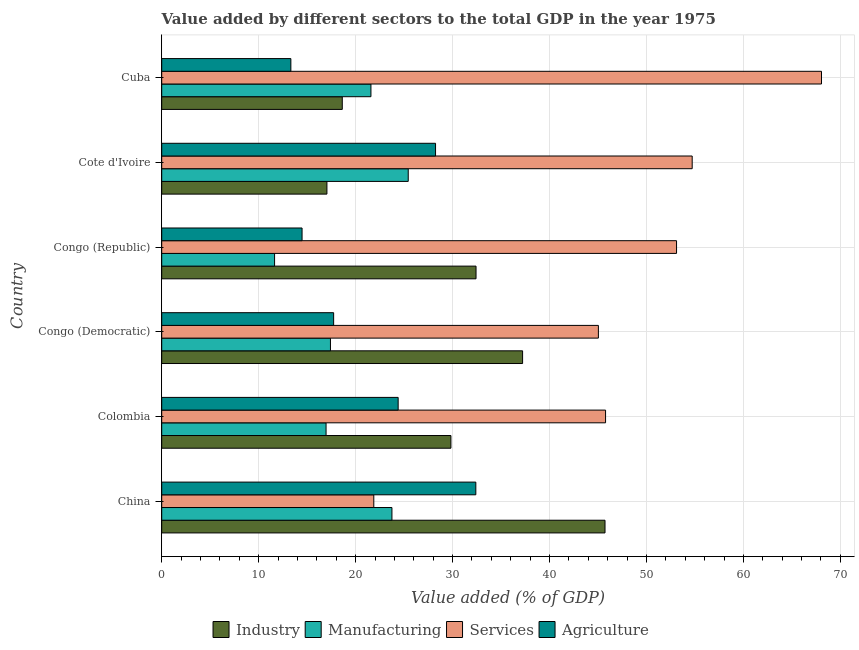How many groups of bars are there?
Make the answer very short. 6. Are the number of bars per tick equal to the number of legend labels?
Provide a short and direct response. Yes. Are the number of bars on each tick of the Y-axis equal?
Give a very brief answer. Yes. How many bars are there on the 4th tick from the bottom?
Give a very brief answer. 4. What is the label of the 4th group of bars from the top?
Offer a very short reply. Congo (Democratic). What is the value added by manufacturing sector in Colombia?
Give a very brief answer. 16.95. Across all countries, what is the maximum value added by industrial sector?
Your response must be concise. 45.72. Across all countries, what is the minimum value added by manufacturing sector?
Provide a succinct answer. 11.64. In which country was the value added by manufacturing sector maximum?
Your answer should be very brief. Cote d'Ivoire. In which country was the value added by industrial sector minimum?
Give a very brief answer. Cote d'Ivoire. What is the total value added by manufacturing sector in the graph?
Offer a very short reply. 116.75. What is the difference between the value added by agricultural sector in Congo (Democratic) and that in Cote d'Ivoire?
Your response must be concise. -10.51. What is the difference between the value added by manufacturing sector in China and the value added by agricultural sector in Colombia?
Your answer should be very brief. -0.64. What is the average value added by agricultural sector per country?
Ensure brevity in your answer.  21.76. What is the difference between the value added by industrial sector and value added by services sector in Congo (Republic)?
Keep it short and to the point. -20.68. What is the ratio of the value added by industrial sector in China to that in Congo (Republic)?
Ensure brevity in your answer.  1.41. Is the value added by services sector in China less than that in Cote d'Ivoire?
Make the answer very short. Yes. What is the difference between the highest and the second highest value added by industrial sector?
Offer a terse response. 8.5. What is the difference between the highest and the lowest value added by agricultural sector?
Your answer should be compact. 19.08. Is the sum of the value added by agricultural sector in China and Cuba greater than the maximum value added by manufacturing sector across all countries?
Make the answer very short. Yes. Is it the case that in every country, the sum of the value added by services sector and value added by industrial sector is greater than the sum of value added by manufacturing sector and value added by agricultural sector?
Provide a succinct answer. Yes. What does the 3rd bar from the top in Congo (Republic) represents?
Offer a terse response. Manufacturing. What does the 4th bar from the bottom in Congo (Republic) represents?
Give a very brief answer. Agriculture. How many bars are there?
Your answer should be compact. 24. How many countries are there in the graph?
Your answer should be compact. 6. What is the difference between two consecutive major ticks on the X-axis?
Your response must be concise. 10. Does the graph contain any zero values?
Keep it short and to the point. No. Does the graph contain grids?
Ensure brevity in your answer.  Yes. Where does the legend appear in the graph?
Your answer should be compact. Bottom center. How many legend labels are there?
Give a very brief answer. 4. How are the legend labels stacked?
Ensure brevity in your answer.  Horizontal. What is the title of the graph?
Make the answer very short. Value added by different sectors to the total GDP in the year 1975. What is the label or title of the X-axis?
Offer a very short reply. Value added (% of GDP). What is the label or title of the Y-axis?
Your response must be concise. Country. What is the Value added (% of GDP) of Industry in China?
Keep it short and to the point. 45.72. What is the Value added (% of GDP) of Manufacturing in China?
Keep it short and to the point. 23.75. What is the Value added (% of GDP) in Services in China?
Make the answer very short. 21.88. What is the Value added (% of GDP) of Agriculture in China?
Give a very brief answer. 32.4. What is the Value added (% of GDP) of Industry in Colombia?
Make the answer very short. 29.83. What is the Value added (% of GDP) of Manufacturing in Colombia?
Give a very brief answer. 16.95. What is the Value added (% of GDP) in Services in Colombia?
Provide a short and direct response. 45.78. What is the Value added (% of GDP) in Agriculture in Colombia?
Give a very brief answer. 24.39. What is the Value added (% of GDP) in Industry in Congo (Democratic)?
Ensure brevity in your answer.  37.22. What is the Value added (% of GDP) in Manufacturing in Congo (Democratic)?
Provide a short and direct response. 17.41. What is the Value added (% of GDP) of Services in Congo (Democratic)?
Your answer should be compact. 45.04. What is the Value added (% of GDP) in Agriculture in Congo (Democratic)?
Give a very brief answer. 17.73. What is the Value added (% of GDP) of Industry in Congo (Republic)?
Give a very brief answer. 32.42. What is the Value added (% of GDP) in Manufacturing in Congo (Republic)?
Provide a succinct answer. 11.64. What is the Value added (% of GDP) of Services in Congo (Republic)?
Ensure brevity in your answer.  53.1. What is the Value added (% of GDP) of Agriculture in Congo (Republic)?
Ensure brevity in your answer.  14.48. What is the Value added (% of GDP) in Industry in Cote d'Ivoire?
Provide a succinct answer. 17.04. What is the Value added (% of GDP) in Manufacturing in Cote d'Ivoire?
Ensure brevity in your answer.  25.43. What is the Value added (% of GDP) in Services in Cote d'Ivoire?
Your response must be concise. 54.72. What is the Value added (% of GDP) of Agriculture in Cote d'Ivoire?
Your answer should be compact. 28.24. What is the Value added (% of GDP) in Industry in Cuba?
Make the answer very short. 18.62. What is the Value added (% of GDP) of Manufacturing in Cuba?
Offer a terse response. 21.58. What is the Value added (% of GDP) of Services in Cuba?
Offer a terse response. 68.05. What is the Value added (% of GDP) of Agriculture in Cuba?
Make the answer very short. 13.32. Across all countries, what is the maximum Value added (% of GDP) in Industry?
Your response must be concise. 45.72. Across all countries, what is the maximum Value added (% of GDP) of Manufacturing?
Provide a short and direct response. 25.43. Across all countries, what is the maximum Value added (% of GDP) of Services?
Provide a succinct answer. 68.05. Across all countries, what is the maximum Value added (% of GDP) in Agriculture?
Offer a very short reply. 32.4. Across all countries, what is the minimum Value added (% of GDP) in Industry?
Provide a succinct answer. 17.04. Across all countries, what is the minimum Value added (% of GDP) in Manufacturing?
Your answer should be compact. 11.64. Across all countries, what is the minimum Value added (% of GDP) of Services?
Give a very brief answer. 21.88. Across all countries, what is the minimum Value added (% of GDP) of Agriculture?
Give a very brief answer. 13.32. What is the total Value added (% of GDP) of Industry in the graph?
Keep it short and to the point. 180.87. What is the total Value added (% of GDP) in Manufacturing in the graph?
Provide a short and direct response. 116.75. What is the total Value added (% of GDP) of Services in the graph?
Ensure brevity in your answer.  288.57. What is the total Value added (% of GDP) of Agriculture in the graph?
Ensure brevity in your answer.  130.56. What is the difference between the Value added (% of GDP) in Industry in China and that in Colombia?
Ensure brevity in your answer.  15.89. What is the difference between the Value added (% of GDP) in Manufacturing in China and that in Colombia?
Ensure brevity in your answer.  6.79. What is the difference between the Value added (% of GDP) of Services in China and that in Colombia?
Keep it short and to the point. -23.9. What is the difference between the Value added (% of GDP) of Agriculture in China and that in Colombia?
Offer a terse response. 8.01. What is the difference between the Value added (% of GDP) of Industry in China and that in Congo (Democratic)?
Your answer should be compact. 8.5. What is the difference between the Value added (% of GDP) in Manufacturing in China and that in Congo (Democratic)?
Offer a terse response. 6.34. What is the difference between the Value added (% of GDP) in Services in China and that in Congo (Democratic)?
Give a very brief answer. -23.17. What is the difference between the Value added (% of GDP) in Agriculture in China and that in Congo (Democratic)?
Provide a succinct answer. 14.66. What is the difference between the Value added (% of GDP) in Industry in China and that in Congo (Republic)?
Offer a very short reply. 13.3. What is the difference between the Value added (% of GDP) in Manufacturing in China and that in Congo (Republic)?
Your answer should be very brief. 12.11. What is the difference between the Value added (% of GDP) in Services in China and that in Congo (Republic)?
Give a very brief answer. -31.23. What is the difference between the Value added (% of GDP) in Agriculture in China and that in Congo (Republic)?
Your answer should be compact. 17.92. What is the difference between the Value added (% of GDP) in Industry in China and that in Cote d'Ivoire?
Provide a short and direct response. 28.68. What is the difference between the Value added (% of GDP) of Manufacturing in China and that in Cote d'Ivoire?
Give a very brief answer. -1.68. What is the difference between the Value added (% of GDP) in Services in China and that in Cote d'Ivoire?
Provide a short and direct response. -32.84. What is the difference between the Value added (% of GDP) in Agriculture in China and that in Cote d'Ivoire?
Ensure brevity in your answer.  4.15. What is the difference between the Value added (% of GDP) in Industry in China and that in Cuba?
Provide a succinct answer. 27.1. What is the difference between the Value added (% of GDP) of Manufacturing in China and that in Cuba?
Offer a very short reply. 2.17. What is the difference between the Value added (% of GDP) of Services in China and that in Cuba?
Offer a very short reply. -46.18. What is the difference between the Value added (% of GDP) of Agriculture in China and that in Cuba?
Provide a succinct answer. 19.08. What is the difference between the Value added (% of GDP) in Industry in Colombia and that in Congo (Democratic)?
Offer a terse response. -7.39. What is the difference between the Value added (% of GDP) in Manufacturing in Colombia and that in Congo (Democratic)?
Offer a terse response. -0.45. What is the difference between the Value added (% of GDP) of Services in Colombia and that in Congo (Democratic)?
Give a very brief answer. 0.74. What is the difference between the Value added (% of GDP) in Agriculture in Colombia and that in Congo (Democratic)?
Give a very brief answer. 6.65. What is the difference between the Value added (% of GDP) of Industry in Colombia and that in Congo (Republic)?
Ensure brevity in your answer.  -2.59. What is the difference between the Value added (% of GDP) of Manufacturing in Colombia and that in Congo (Republic)?
Make the answer very short. 5.31. What is the difference between the Value added (% of GDP) of Services in Colombia and that in Congo (Republic)?
Your response must be concise. -7.32. What is the difference between the Value added (% of GDP) of Agriculture in Colombia and that in Congo (Republic)?
Give a very brief answer. 9.91. What is the difference between the Value added (% of GDP) of Industry in Colombia and that in Cote d'Ivoire?
Offer a very short reply. 12.79. What is the difference between the Value added (% of GDP) in Manufacturing in Colombia and that in Cote d'Ivoire?
Offer a very short reply. -8.48. What is the difference between the Value added (% of GDP) of Services in Colombia and that in Cote d'Ivoire?
Give a very brief answer. -8.93. What is the difference between the Value added (% of GDP) in Agriculture in Colombia and that in Cote d'Ivoire?
Provide a short and direct response. -3.86. What is the difference between the Value added (% of GDP) of Industry in Colombia and that in Cuba?
Provide a short and direct response. 11.21. What is the difference between the Value added (% of GDP) in Manufacturing in Colombia and that in Cuba?
Offer a very short reply. -4.63. What is the difference between the Value added (% of GDP) of Services in Colombia and that in Cuba?
Your answer should be compact. -22.27. What is the difference between the Value added (% of GDP) in Agriculture in Colombia and that in Cuba?
Offer a very short reply. 11.07. What is the difference between the Value added (% of GDP) of Industry in Congo (Democratic) and that in Congo (Republic)?
Your answer should be compact. 4.8. What is the difference between the Value added (% of GDP) of Manufacturing in Congo (Democratic) and that in Congo (Republic)?
Provide a short and direct response. 5.76. What is the difference between the Value added (% of GDP) of Services in Congo (Democratic) and that in Congo (Republic)?
Give a very brief answer. -8.06. What is the difference between the Value added (% of GDP) in Agriculture in Congo (Democratic) and that in Congo (Republic)?
Your answer should be very brief. 3.26. What is the difference between the Value added (% of GDP) in Industry in Congo (Democratic) and that in Cote d'Ivoire?
Your answer should be very brief. 20.18. What is the difference between the Value added (% of GDP) in Manufacturing in Congo (Democratic) and that in Cote d'Ivoire?
Ensure brevity in your answer.  -8.02. What is the difference between the Value added (% of GDP) in Services in Congo (Democratic) and that in Cote d'Ivoire?
Provide a short and direct response. -9.67. What is the difference between the Value added (% of GDP) of Agriculture in Congo (Democratic) and that in Cote d'Ivoire?
Your answer should be very brief. -10.51. What is the difference between the Value added (% of GDP) in Industry in Congo (Democratic) and that in Cuba?
Keep it short and to the point. 18.6. What is the difference between the Value added (% of GDP) in Manufacturing in Congo (Democratic) and that in Cuba?
Offer a very short reply. -4.17. What is the difference between the Value added (% of GDP) in Services in Congo (Democratic) and that in Cuba?
Give a very brief answer. -23.01. What is the difference between the Value added (% of GDP) in Agriculture in Congo (Democratic) and that in Cuba?
Provide a succinct answer. 4.41. What is the difference between the Value added (% of GDP) of Industry in Congo (Republic) and that in Cote d'Ivoire?
Your answer should be very brief. 15.38. What is the difference between the Value added (% of GDP) of Manufacturing in Congo (Republic) and that in Cote d'Ivoire?
Ensure brevity in your answer.  -13.79. What is the difference between the Value added (% of GDP) of Services in Congo (Republic) and that in Cote d'Ivoire?
Make the answer very short. -1.61. What is the difference between the Value added (% of GDP) in Agriculture in Congo (Republic) and that in Cote d'Ivoire?
Your response must be concise. -13.77. What is the difference between the Value added (% of GDP) of Industry in Congo (Republic) and that in Cuba?
Provide a short and direct response. 13.8. What is the difference between the Value added (% of GDP) of Manufacturing in Congo (Republic) and that in Cuba?
Offer a terse response. -9.94. What is the difference between the Value added (% of GDP) in Services in Congo (Republic) and that in Cuba?
Offer a terse response. -14.95. What is the difference between the Value added (% of GDP) of Agriculture in Congo (Republic) and that in Cuba?
Offer a terse response. 1.16. What is the difference between the Value added (% of GDP) of Industry in Cote d'Ivoire and that in Cuba?
Ensure brevity in your answer.  -1.58. What is the difference between the Value added (% of GDP) in Manufacturing in Cote d'Ivoire and that in Cuba?
Provide a succinct answer. 3.85. What is the difference between the Value added (% of GDP) in Services in Cote d'Ivoire and that in Cuba?
Make the answer very short. -13.34. What is the difference between the Value added (% of GDP) of Agriculture in Cote d'Ivoire and that in Cuba?
Give a very brief answer. 14.92. What is the difference between the Value added (% of GDP) in Industry in China and the Value added (% of GDP) in Manufacturing in Colombia?
Provide a short and direct response. 28.77. What is the difference between the Value added (% of GDP) in Industry in China and the Value added (% of GDP) in Services in Colombia?
Your answer should be very brief. -0.06. What is the difference between the Value added (% of GDP) of Industry in China and the Value added (% of GDP) of Agriculture in Colombia?
Keep it short and to the point. 21.34. What is the difference between the Value added (% of GDP) of Manufacturing in China and the Value added (% of GDP) of Services in Colombia?
Make the answer very short. -22.03. What is the difference between the Value added (% of GDP) in Manufacturing in China and the Value added (% of GDP) in Agriculture in Colombia?
Your answer should be very brief. -0.64. What is the difference between the Value added (% of GDP) in Services in China and the Value added (% of GDP) in Agriculture in Colombia?
Give a very brief answer. -2.51. What is the difference between the Value added (% of GDP) of Industry in China and the Value added (% of GDP) of Manufacturing in Congo (Democratic)?
Offer a terse response. 28.32. What is the difference between the Value added (% of GDP) in Industry in China and the Value added (% of GDP) in Services in Congo (Democratic)?
Provide a succinct answer. 0.68. What is the difference between the Value added (% of GDP) in Industry in China and the Value added (% of GDP) in Agriculture in Congo (Democratic)?
Offer a terse response. 27.99. What is the difference between the Value added (% of GDP) in Manufacturing in China and the Value added (% of GDP) in Services in Congo (Democratic)?
Your answer should be compact. -21.3. What is the difference between the Value added (% of GDP) in Manufacturing in China and the Value added (% of GDP) in Agriculture in Congo (Democratic)?
Your answer should be compact. 6.01. What is the difference between the Value added (% of GDP) of Services in China and the Value added (% of GDP) of Agriculture in Congo (Democratic)?
Offer a very short reply. 4.14. What is the difference between the Value added (% of GDP) of Industry in China and the Value added (% of GDP) of Manufacturing in Congo (Republic)?
Make the answer very short. 34.08. What is the difference between the Value added (% of GDP) in Industry in China and the Value added (% of GDP) in Services in Congo (Republic)?
Provide a short and direct response. -7.38. What is the difference between the Value added (% of GDP) of Industry in China and the Value added (% of GDP) of Agriculture in Congo (Republic)?
Provide a succinct answer. 31.25. What is the difference between the Value added (% of GDP) of Manufacturing in China and the Value added (% of GDP) of Services in Congo (Republic)?
Make the answer very short. -29.36. What is the difference between the Value added (% of GDP) of Manufacturing in China and the Value added (% of GDP) of Agriculture in Congo (Republic)?
Offer a very short reply. 9.27. What is the difference between the Value added (% of GDP) in Services in China and the Value added (% of GDP) in Agriculture in Congo (Republic)?
Give a very brief answer. 7.4. What is the difference between the Value added (% of GDP) in Industry in China and the Value added (% of GDP) in Manufacturing in Cote d'Ivoire?
Your response must be concise. 20.3. What is the difference between the Value added (% of GDP) of Industry in China and the Value added (% of GDP) of Services in Cote d'Ivoire?
Offer a terse response. -8.99. What is the difference between the Value added (% of GDP) in Industry in China and the Value added (% of GDP) in Agriculture in Cote d'Ivoire?
Keep it short and to the point. 17.48. What is the difference between the Value added (% of GDP) in Manufacturing in China and the Value added (% of GDP) in Services in Cote d'Ivoire?
Ensure brevity in your answer.  -30.97. What is the difference between the Value added (% of GDP) of Manufacturing in China and the Value added (% of GDP) of Agriculture in Cote d'Ivoire?
Provide a succinct answer. -4.5. What is the difference between the Value added (% of GDP) of Services in China and the Value added (% of GDP) of Agriculture in Cote d'Ivoire?
Give a very brief answer. -6.37. What is the difference between the Value added (% of GDP) in Industry in China and the Value added (% of GDP) in Manufacturing in Cuba?
Keep it short and to the point. 24.14. What is the difference between the Value added (% of GDP) of Industry in China and the Value added (% of GDP) of Services in Cuba?
Your answer should be compact. -22.33. What is the difference between the Value added (% of GDP) of Industry in China and the Value added (% of GDP) of Agriculture in Cuba?
Offer a terse response. 32.4. What is the difference between the Value added (% of GDP) in Manufacturing in China and the Value added (% of GDP) in Services in Cuba?
Your answer should be very brief. -44.31. What is the difference between the Value added (% of GDP) of Manufacturing in China and the Value added (% of GDP) of Agriculture in Cuba?
Your response must be concise. 10.43. What is the difference between the Value added (% of GDP) of Services in China and the Value added (% of GDP) of Agriculture in Cuba?
Ensure brevity in your answer.  8.56. What is the difference between the Value added (% of GDP) of Industry in Colombia and the Value added (% of GDP) of Manufacturing in Congo (Democratic)?
Provide a succinct answer. 12.43. What is the difference between the Value added (% of GDP) of Industry in Colombia and the Value added (% of GDP) of Services in Congo (Democratic)?
Your answer should be very brief. -15.21. What is the difference between the Value added (% of GDP) in Industry in Colombia and the Value added (% of GDP) in Agriculture in Congo (Democratic)?
Your answer should be compact. 12.1. What is the difference between the Value added (% of GDP) in Manufacturing in Colombia and the Value added (% of GDP) in Services in Congo (Democratic)?
Provide a succinct answer. -28.09. What is the difference between the Value added (% of GDP) of Manufacturing in Colombia and the Value added (% of GDP) of Agriculture in Congo (Democratic)?
Your answer should be compact. -0.78. What is the difference between the Value added (% of GDP) in Services in Colombia and the Value added (% of GDP) in Agriculture in Congo (Democratic)?
Make the answer very short. 28.05. What is the difference between the Value added (% of GDP) of Industry in Colombia and the Value added (% of GDP) of Manufacturing in Congo (Republic)?
Offer a very short reply. 18.19. What is the difference between the Value added (% of GDP) in Industry in Colombia and the Value added (% of GDP) in Services in Congo (Republic)?
Make the answer very short. -23.27. What is the difference between the Value added (% of GDP) in Industry in Colombia and the Value added (% of GDP) in Agriculture in Congo (Republic)?
Offer a terse response. 15.35. What is the difference between the Value added (% of GDP) of Manufacturing in Colombia and the Value added (% of GDP) of Services in Congo (Republic)?
Provide a succinct answer. -36.15. What is the difference between the Value added (% of GDP) in Manufacturing in Colombia and the Value added (% of GDP) in Agriculture in Congo (Republic)?
Ensure brevity in your answer.  2.47. What is the difference between the Value added (% of GDP) in Services in Colombia and the Value added (% of GDP) in Agriculture in Congo (Republic)?
Offer a terse response. 31.3. What is the difference between the Value added (% of GDP) in Industry in Colombia and the Value added (% of GDP) in Manufacturing in Cote d'Ivoire?
Ensure brevity in your answer.  4.4. What is the difference between the Value added (% of GDP) of Industry in Colombia and the Value added (% of GDP) of Services in Cote d'Ivoire?
Provide a short and direct response. -24.88. What is the difference between the Value added (% of GDP) of Industry in Colombia and the Value added (% of GDP) of Agriculture in Cote d'Ivoire?
Your response must be concise. 1.59. What is the difference between the Value added (% of GDP) of Manufacturing in Colombia and the Value added (% of GDP) of Services in Cote d'Ivoire?
Provide a succinct answer. -37.76. What is the difference between the Value added (% of GDP) in Manufacturing in Colombia and the Value added (% of GDP) in Agriculture in Cote d'Ivoire?
Provide a short and direct response. -11.29. What is the difference between the Value added (% of GDP) in Services in Colombia and the Value added (% of GDP) in Agriculture in Cote d'Ivoire?
Your response must be concise. 17.54. What is the difference between the Value added (% of GDP) in Industry in Colombia and the Value added (% of GDP) in Manufacturing in Cuba?
Make the answer very short. 8.25. What is the difference between the Value added (% of GDP) in Industry in Colombia and the Value added (% of GDP) in Services in Cuba?
Give a very brief answer. -38.22. What is the difference between the Value added (% of GDP) in Industry in Colombia and the Value added (% of GDP) in Agriculture in Cuba?
Offer a terse response. 16.51. What is the difference between the Value added (% of GDP) of Manufacturing in Colombia and the Value added (% of GDP) of Services in Cuba?
Your answer should be compact. -51.1. What is the difference between the Value added (% of GDP) in Manufacturing in Colombia and the Value added (% of GDP) in Agriculture in Cuba?
Make the answer very short. 3.63. What is the difference between the Value added (% of GDP) in Services in Colombia and the Value added (% of GDP) in Agriculture in Cuba?
Provide a short and direct response. 32.46. What is the difference between the Value added (% of GDP) of Industry in Congo (Democratic) and the Value added (% of GDP) of Manufacturing in Congo (Republic)?
Provide a short and direct response. 25.58. What is the difference between the Value added (% of GDP) of Industry in Congo (Democratic) and the Value added (% of GDP) of Services in Congo (Republic)?
Keep it short and to the point. -15.88. What is the difference between the Value added (% of GDP) in Industry in Congo (Democratic) and the Value added (% of GDP) in Agriculture in Congo (Republic)?
Offer a very short reply. 22.75. What is the difference between the Value added (% of GDP) of Manufacturing in Congo (Democratic) and the Value added (% of GDP) of Services in Congo (Republic)?
Give a very brief answer. -35.7. What is the difference between the Value added (% of GDP) in Manufacturing in Congo (Democratic) and the Value added (% of GDP) in Agriculture in Congo (Republic)?
Give a very brief answer. 2.93. What is the difference between the Value added (% of GDP) in Services in Congo (Democratic) and the Value added (% of GDP) in Agriculture in Congo (Republic)?
Your answer should be compact. 30.56. What is the difference between the Value added (% of GDP) in Industry in Congo (Democratic) and the Value added (% of GDP) in Manufacturing in Cote d'Ivoire?
Your answer should be compact. 11.8. What is the difference between the Value added (% of GDP) of Industry in Congo (Democratic) and the Value added (% of GDP) of Services in Cote d'Ivoire?
Give a very brief answer. -17.49. What is the difference between the Value added (% of GDP) in Industry in Congo (Democratic) and the Value added (% of GDP) in Agriculture in Cote d'Ivoire?
Make the answer very short. 8.98. What is the difference between the Value added (% of GDP) of Manufacturing in Congo (Democratic) and the Value added (% of GDP) of Services in Cote d'Ivoire?
Offer a very short reply. -37.31. What is the difference between the Value added (% of GDP) of Manufacturing in Congo (Democratic) and the Value added (% of GDP) of Agriculture in Cote d'Ivoire?
Make the answer very short. -10.84. What is the difference between the Value added (% of GDP) of Services in Congo (Democratic) and the Value added (% of GDP) of Agriculture in Cote d'Ivoire?
Provide a succinct answer. 16.8. What is the difference between the Value added (% of GDP) of Industry in Congo (Democratic) and the Value added (% of GDP) of Manufacturing in Cuba?
Provide a short and direct response. 15.64. What is the difference between the Value added (% of GDP) of Industry in Congo (Democratic) and the Value added (% of GDP) of Services in Cuba?
Your answer should be very brief. -30.83. What is the difference between the Value added (% of GDP) in Industry in Congo (Democratic) and the Value added (% of GDP) in Agriculture in Cuba?
Your answer should be compact. 23.9. What is the difference between the Value added (% of GDP) in Manufacturing in Congo (Democratic) and the Value added (% of GDP) in Services in Cuba?
Provide a short and direct response. -50.65. What is the difference between the Value added (% of GDP) in Manufacturing in Congo (Democratic) and the Value added (% of GDP) in Agriculture in Cuba?
Your answer should be very brief. 4.08. What is the difference between the Value added (% of GDP) of Services in Congo (Democratic) and the Value added (% of GDP) of Agriculture in Cuba?
Offer a terse response. 31.72. What is the difference between the Value added (% of GDP) in Industry in Congo (Republic) and the Value added (% of GDP) in Manufacturing in Cote d'Ivoire?
Make the answer very short. 6.99. What is the difference between the Value added (% of GDP) of Industry in Congo (Republic) and the Value added (% of GDP) of Services in Cote d'Ivoire?
Ensure brevity in your answer.  -22.29. What is the difference between the Value added (% of GDP) of Industry in Congo (Republic) and the Value added (% of GDP) of Agriculture in Cote d'Ivoire?
Your response must be concise. 4.18. What is the difference between the Value added (% of GDP) in Manufacturing in Congo (Republic) and the Value added (% of GDP) in Services in Cote d'Ivoire?
Keep it short and to the point. -43.07. What is the difference between the Value added (% of GDP) of Manufacturing in Congo (Republic) and the Value added (% of GDP) of Agriculture in Cote d'Ivoire?
Your answer should be compact. -16.6. What is the difference between the Value added (% of GDP) of Services in Congo (Republic) and the Value added (% of GDP) of Agriculture in Cote d'Ivoire?
Your answer should be compact. 24.86. What is the difference between the Value added (% of GDP) in Industry in Congo (Republic) and the Value added (% of GDP) in Manufacturing in Cuba?
Give a very brief answer. 10.84. What is the difference between the Value added (% of GDP) of Industry in Congo (Republic) and the Value added (% of GDP) of Services in Cuba?
Your answer should be very brief. -35.63. What is the difference between the Value added (% of GDP) in Industry in Congo (Republic) and the Value added (% of GDP) in Agriculture in Cuba?
Offer a very short reply. 19.1. What is the difference between the Value added (% of GDP) in Manufacturing in Congo (Republic) and the Value added (% of GDP) in Services in Cuba?
Keep it short and to the point. -56.41. What is the difference between the Value added (% of GDP) of Manufacturing in Congo (Republic) and the Value added (% of GDP) of Agriculture in Cuba?
Offer a very short reply. -1.68. What is the difference between the Value added (% of GDP) in Services in Congo (Republic) and the Value added (% of GDP) in Agriculture in Cuba?
Keep it short and to the point. 39.78. What is the difference between the Value added (% of GDP) of Industry in Cote d'Ivoire and the Value added (% of GDP) of Manufacturing in Cuba?
Offer a terse response. -4.54. What is the difference between the Value added (% of GDP) in Industry in Cote d'Ivoire and the Value added (% of GDP) in Services in Cuba?
Offer a terse response. -51.01. What is the difference between the Value added (% of GDP) of Industry in Cote d'Ivoire and the Value added (% of GDP) of Agriculture in Cuba?
Your response must be concise. 3.72. What is the difference between the Value added (% of GDP) of Manufacturing in Cote d'Ivoire and the Value added (% of GDP) of Services in Cuba?
Offer a very short reply. -42.63. What is the difference between the Value added (% of GDP) in Manufacturing in Cote d'Ivoire and the Value added (% of GDP) in Agriculture in Cuba?
Your response must be concise. 12.11. What is the difference between the Value added (% of GDP) in Services in Cote d'Ivoire and the Value added (% of GDP) in Agriculture in Cuba?
Give a very brief answer. 41.39. What is the average Value added (% of GDP) in Industry per country?
Your answer should be very brief. 30.14. What is the average Value added (% of GDP) in Manufacturing per country?
Ensure brevity in your answer.  19.46. What is the average Value added (% of GDP) of Services per country?
Provide a succinct answer. 48.1. What is the average Value added (% of GDP) of Agriculture per country?
Your answer should be compact. 21.76. What is the difference between the Value added (% of GDP) of Industry and Value added (% of GDP) of Manufacturing in China?
Your response must be concise. 21.98. What is the difference between the Value added (% of GDP) in Industry and Value added (% of GDP) in Services in China?
Make the answer very short. 23.85. What is the difference between the Value added (% of GDP) in Industry and Value added (% of GDP) in Agriculture in China?
Your answer should be very brief. 13.33. What is the difference between the Value added (% of GDP) in Manufacturing and Value added (% of GDP) in Services in China?
Provide a short and direct response. 1.87. What is the difference between the Value added (% of GDP) in Manufacturing and Value added (% of GDP) in Agriculture in China?
Give a very brief answer. -8.65. What is the difference between the Value added (% of GDP) in Services and Value added (% of GDP) in Agriculture in China?
Keep it short and to the point. -10.52. What is the difference between the Value added (% of GDP) of Industry and Value added (% of GDP) of Manufacturing in Colombia?
Make the answer very short. 12.88. What is the difference between the Value added (% of GDP) in Industry and Value added (% of GDP) in Services in Colombia?
Offer a very short reply. -15.95. What is the difference between the Value added (% of GDP) of Industry and Value added (% of GDP) of Agriculture in Colombia?
Keep it short and to the point. 5.44. What is the difference between the Value added (% of GDP) in Manufacturing and Value added (% of GDP) in Services in Colombia?
Your response must be concise. -28.83. What is the difference between the Value added (% of GDP) of Manufacturing and Value added (% of GDP) of Agriculture in Colombia?
Your answer should be very brief. -7.44. What is the difference between the Value added (% of GDP) of Services and Value added (% of GDP) of Agriculture in Colombia?
Keep it short and to the point. 21.39. What is the difference between the Value added (% of GDP) of Industry and Value added (% of GDP) of Manufacturing in Congo (Democratic)?
Provide a short and direct response. 19.82. What is the difference between the Value added (% of GDP) of Industry and Value added (% of GDP) of Services in Congo (Democratic)?
Make the answer very short. -7.82. What is the difference between the Value added (% of GDP) of Industry and Value added (% of GDP) of Agriculture in Congo (Democratic)?
Offer a terse response. 19.49. What is the difference between the Value added (% of GDP) of Manufacturing and Value added (% of GDP) of Services in Congo (Democratic)?
Give a very brief answer. -27.64. What is the difference between the Value added (% of GDP) in Manufacturing and Value added (% of GDP) in Agriculture in Congo (Democratic)?
Your answer should be very brief. -0.33. What is the difference between the Value added (% of GDP) in Services and Value added (% of GDP) in Agriculture in Congo (Democratic)?
Your response must be concise. 27.31. What is the difference between the Value added (% of GDP) in Industry and Value added (% of GDP) in Manufacturing in Congo (Republic)?
Provide a succinct answer. 20.78. What is the difference between the Value added (% of GDP) of Industry and Value added (% of GDP) of Services in Congo (Republic)?
Ensure brevity in your answer.  -20.68. What is the difference between the Value added (% of GDP) in Industry and Value added (% of GDP) in Agriculture in Congo (Republic)?
Your answer should be very brief. 17.94. What is the difference between the Value added (% of GDP) in Manufacturing and Value added (% of GDP) in Services in Congo (Republic)?
Keep it short and to the point. -41.46. What is the difference between the Value added (% of GDP) in Manufacturing and Value added (% of GDP) in Agriculture in Congo (Republic)?
Give a very brief answer. -2.84. What is the difference between the Value added (% of GDP) of Services and Value added (% of GDP) of Agriculture in Congo (Republic)?
Make the answer very short. 38.63. What is the difference between the Value added (% of GDP) in Industry and Value added (% of GDP) in Manufacturing in Cote d'Ivoire?
Offer a terse response. -8.39. What is the difference between the Value added (% of GDP) of Industry and Value added (% of GDP) of Services in Cote d'Ivoire?
Your answer should be very brief. -37.68. What is the difference between the Value added (% of GDP) in Industry and Value added (% of GDP) in Agriculture in Cote d'Ivoire?
Ensure brevity in your answer.  -11.2. What is the difference between the Value added (% of GDP) in Manufacturing and Value added (% of GDP) in Services in Cote d'Ivoire?
Your response must be concise. -29.29. What is the difference between the Value added (% of GDP) in Manufacturing and Value added (% of GDP) in Agriculture in Cote d'Ivoire?
Give a very brief answer. -2.82. What is the difference between the Value added (% of GDP) in Services and Value added (% of GDP) in Agriculture in Cote d'Ivoire?
Keep it short and to the point. 26.47. What is the difference between the Value added (% of GDP) in Industry and Value added (% of GDP) in Manufacturing in Cuba?
Make the answer very short. -2.96. What is the difference between the Value added (% of GDP) in Industry and Value added (% of GDP) in Services in Cuba?
Your answer should be compact. -49.43. What is the difference between the Value added (% of GDP) in Industry and Value added (% of GDP) in Agriculture in Cuba?
Provide a succinct answer. 5.3. What is the difference between the Value added (% of GDP) in Manufacturing and Value added (% of GDP) in Services in Cuba?
Your answer should be very brief. -46.47. What is the difference between the Value added (% of GDP) in Manufacturing and Value added (% of GDP) in Agriculture in Cuba?
Your answer should be very brief. 8.26. What is the difference between the Value added (% of GDP) in Services and Value added (% of GDP) in Agriculture in Cuba?
Offer a terse response. 54.73. What is the ratio of the Value added (% of GDP) of Industry in China to that in Colombia?
Offer a very short reply. 1.53. What is the ratio of the Value added (% of GDP) in Manufacturing in China to that in Colombia?
Give a very brief answer. 1.4. What is the ratio of the Value added (% of GDP) in Services in China to that in Colombia?
Provide a short and direct response. 0.48. What is the ratio of the Value added (% of GDP) in Agriculture in China to that in Colombia?
Provide a short and direct response. 1.33. What is the ratio of the Value added (% of GDP) of Industry in China to that in Congo (Democratic)?
Ensure brevity in your answer.  1.23. What is the ratio of the Value added (% of GDP) in Manufacturing in China to that in Congo (Democratic)?
Your answer should be compact. 1.36. What is the ratio of the Value added (% of GDP) of Services in China to that in Congo (Democratic)?
Give a very brief answer. 0.49. What is the ratio of the Value added (% of GDP) of Agriculture in China to that in Congo (Democratic)?
Give a very brief answer. 1.83. What is the ratio of the Value added (% of GDP) in Industry in China to that in Congo (Republic)?
Your answer should be compact. 1.41. What is the ratio of the Value added (% of GDP) of Manufacturing in China to that in Congo (Republic)?
Offer a terse response. 2.04. What is the ratio of the Value added (% of GDP) in Services in China to that in Congo (Republic)?
Your response must be concise. 0.41. What is the ratio of the Value added (% of GDP) in Agriculture in China to that in Congo (Republic)?
Provide a short and direct response. 2.24. What is the ratio of the Value added (% of GDP) of Industry in China to that in Cote d'Ivoire?
Your answer should be very brief. 2.68. What is the ratio of the Value added (% of GDP) in Manufacturing in China to that in Cote d'Ivoire?
Make the answer very short. 0.93. What is the ratio of the Value added (% of GDP) in Services in China to that in Cote d'Ivoire?
Give a very brief answer. 0.4. What is the ratio of the Value added (% of GDP) of Agriculture in China to that in Cote d'Ivoire?
Provide a short and direct response. 1.15. What is the ratio of the Value added (% of GDP) of Industry in China to that in Cuba?
Your answer should be compact. 2.46. What is the ratio of the Value added (% of GDP) of Manufacturing in China to that in Cuba?
Provide a short and direct response. 1.1. What is the ratio of the Value added (% of GDP) in Services in China to that in Cuba?
Provide a succinct answer. 0.32. What is the ratio of the Value added (% of GDP) of Agriculture in China to that in Cuba?
Your response must be concise. 2.43. What is the ratio of the Value added (% of GDP) in Industry in Colombia to that in Congo (Democratic)?
Your answer should be very brief. 0.8. What is the ratio of the Value added (% of GDP) in Manufacturing in Colombia to that in Congo (Democratic)?
Provide a succinct answer. 0.97. What is the ratio of the Value added (% of GDP) in Services in Colombia to that in Congo (Democratic)?
Your answer should be compact. 1.02. What is the ratio of the Value added (% of GDP) of Agriculture in Colombia to that in Congo (Democratic)?
Give a very brief answer. 1.38. What is the ratio of the Value added (% of GDP) in Industry in Colombia to that in Congo (Republic)?
Provide a succinct answer. 0.92. What is the ratio of the Value added (% of GDP) of Manufacturing in Colombia to that in Congo (Republic)?
Provide a short and direct response. 1.46. What is the ratio of the Value added (% of GDP) in Services in Colombia to that in Congo (Republic)?
Offer a very short reply. 0.86. What is the ratio of the Value added (% of GDP) of Agriculture in Colombia to that in Congo (Republic)?
Offer a terse response. 1.68. What is the ratio of the Value added (% of GDP) of Industry in Colombia to that in Cote d'Ivoire?
Provide a short and direct response. 1.75. What is the ratio of the Value added (% of GDP) in Services in Colombia to that in Cote d'Ivoire?
Keep it short and to the point. 0.84. What is the ratio of the Value added (% of GDP) in Agriculture in Colombia to that in Cote d'Ivoire?
Offer a very short reply. 0.86. What is the ratio of the Value added (% of GDP) of Industry in Colombia to that in Cuba?
Keep it short and to the point. 1.6. What is the ratio of the Value added (% of GDP) of Manufacturing in Colombia to that in Cuba?
Your answer should be very brief. 0.79. What is the ratio of the Value added (% of GDP) of Services in Colombia to that in Cuba?
Make the answer very short. 0.67. What is the ratio of the Value added (% of GDP) of Agriculture in Colombia to that in Cuba?
Your response must be concise. 1.83. What is the ratio of the Value added (% of GDP) of Industry in Congo (Democratic) to that in Congo (Republic)?
Offer a very short reply. 1.15. What is the ratio of the Value added (% of GDP) of Manufacturing in Congo (Democratic) to that in Congo (Republic)?
Give a very brief answer. 1.5. What is the ratio of the Value added (% of GDP) in Services in Congo (Democratic) to that in Congo (Republic)?
Keep it short and to the point. 0.85. What is the ratio of the Value added (% of GDP) in Agriculture in Congo (Democratic) to that in Congo (Republic)?
Offer a very short reply. 1.23. What is the ratio of the Value added (% of GDP) of Industry in Congo (Democratic) to that in Cote d'Ivoire?
Ensure brevity in your answer.  2.18. What is the ratio of the Value added (% of GDP) in Manufacturing in Congo (Democratic) to that in Cote d'Ivoire?
Offer a very short reply. 0.68. What is the ratio of the Value added (% of GDP) in Services in Congo (Democratic) to that in Cote d'Ivoire?
Provide a short and direct response. 0.82. What is the ratio of the Value added (% of GDP) in Agriculture in Congo (Democratic) to that in Cote d'Ivoire?
Offer a terse response. 0.63. What is the ratio of the Value added (% of GDP) in Industry in Congo (Democratic) to that in Cuba?
Make the answer very short. 2. What is the ratio of the Value added (% of GDP) of Manufacturing in Congo (Democratic) to that in Cuba?
Ensure brevity in your answer.  0.81. What is the ratio of the Value added (% of GDP) of Services in Congo (Democratic) to that in Cuba?
Your answer should be compact. 0.66. What is the ratio of the Value added (% of GDP) in Agriculture in Congo (Democratic) to that in Cuba?
Your response must be concise. 1.33. What is the ratio of the Value added (% of GDP) in Industry in Congo (Republic) to that in Cote d'Ivoire?
Keep it short and to the point. 1.9. What is the ratio of the Value added (% of GDP) of Manufacturing in Congo (Republic) to that in Cote d'Ivoire?
Offer a terse response. 0.46. What is the ratio of the Value added (% of GDP) of Services in Congo (Republic) to that in Cote d'Ivoire?
Ensure brevity in your answer.  0.97. What is the ratio of the Value added (% of GDP) of Agriculture in Congo (Republic) to that in Cote d'Ivoire?
Your response must be concise. 0.51. What is the ratio of the Value added (% of GDP) of Industry in Congo (Republic) to that in Cuba?
Provide a succinct answer. 1.74. What is the ratio of the Value added (% of GDP) in Manufacturing in Congo (Republic) to that in Cuba?
Provide a succinct answer. 0.54. What is the ratio of the Value added (% of GDP) in Services in Congo (Republic) to that in Cuba?
Provide a short and direct response. 0.78. What is the ratio of the Value added (% of GDP) in Agriculture in Congo (Republic) to that in Cuba?
Ensure brevity in your answer.  1.09. What is the ratio of the Value added (% of GDP) in Industry in Cote d'Ivoire to that in Cuba?
Ensure brevity in your answer.  0.91. What is the ratio of the Value added (% of GDP) in Manufacturing in Cote d'Ivoire to that in Cuba?
Provide a succinct answer. 1.18. What is the ratio of the Value added (% of GDP) of Services in Cote d'Ivoire to that in Cuba?
Give a very brief answer. 0.8. What is the ratio of the Value added (% of GDP) in Agriculture in Cote d'Ivoire to that in Cuba?
Provide a succinct answer. 2.12. What is the difference between the highest and the second highest Value added (% of GDP) of Industry?
Offer a terse response. 8.5. What is the difference between the highest and the second highest Value added (% of GDP) of Manufacturing?
Your answer should be very brief. 1.68. What is the difference between the highest and the second highest Value added (% of GDP) in Services?
Your answer should be very brief. 13.34. What is the difference between the highest and the second highest Value added (% of GDP) of Agriculture?
Keep it short and to the point. 4.15. What is the difference between the highest and the lowest Value added (% of GDP) of Industry?
Your answer should be very brief. 28.68. What is the difference between the highest and the lowest Value added (% of GDP) of Manufacturing?
Give a very brief answer. 13.79. What is the difference between the highest and the lowest Value added (% of GDP) of Services?
Your response must be concise. 46.18. What is the difference between the highest and the lowest Value added (% of GDP) of Agriculture?
Offer a terse response. 19.08. 